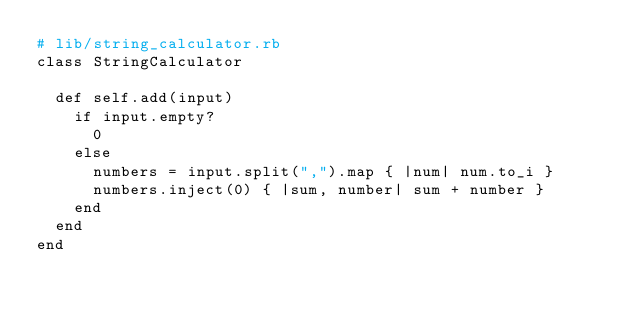Convert code to text. <code><loc_0><loc_0><loc_500><loc_500><_Ruby_># lib/string_calculator.rb
class StringCalculator

  def self.add(input)
    if input.empty?
      0
    else
      numbers = input.split(",").map { |num| num.to_i }
      numbers.inject(0) { |sum, number| sum + number }
    end
  end
end</code> 